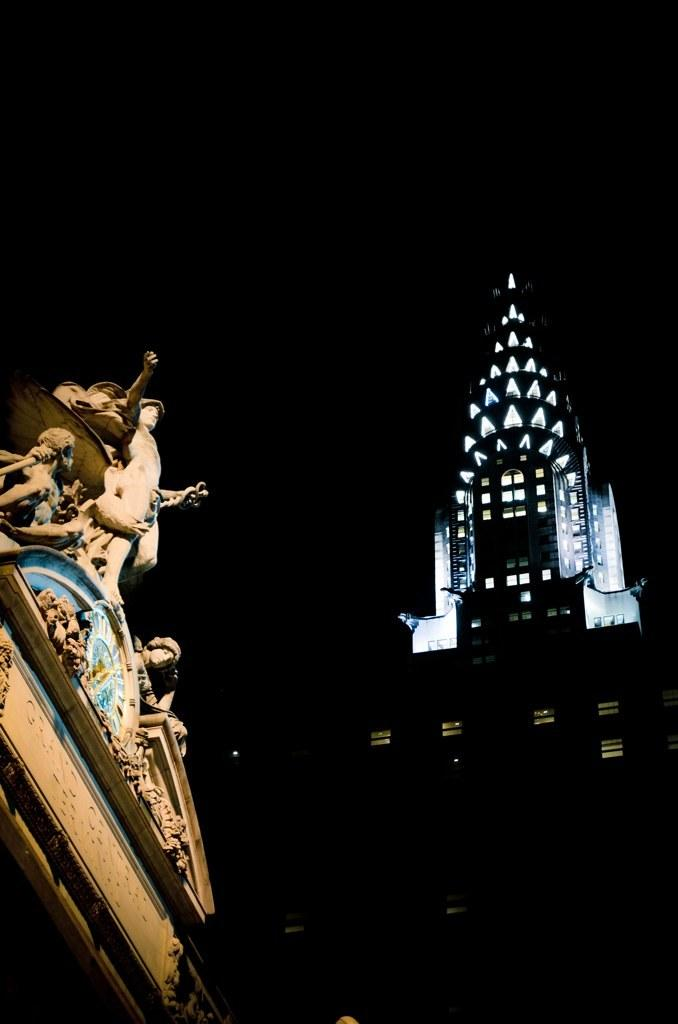What can be found on the left side of the image? There are statues on the left side of the image. What is visible in the background of the image? There is a building in the background of the image. What type of reading material is the statue holding in the image? There are no statues holding reading material in the image, as the statues do not have any visible objects in their hands. 